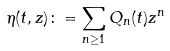Convert formula to latex. <formula><loc_0><loc_0><loc_500><loc_500>\eta ( t , z ) \colon = \sum _ { n \geq 1 } Q _ { n } ( t ) z ^ { n }</formula> 